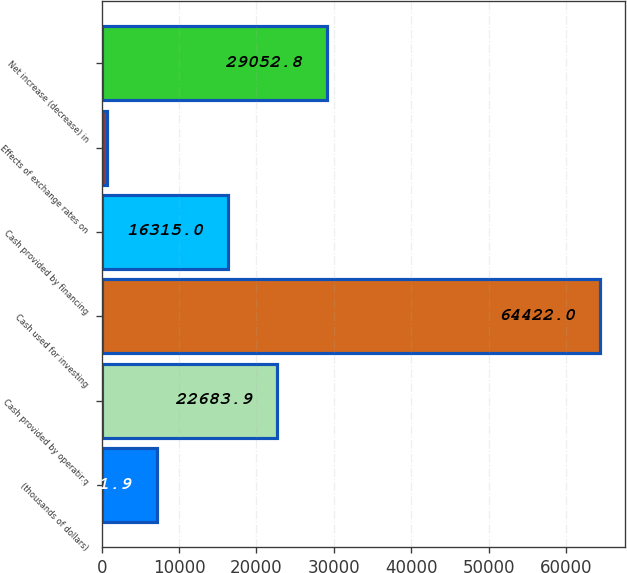<chart> <loc_0><loc_0><loc_500><loc_500><bar_chart><fcel>(thousands of dollars)<fcel>Cash provided by operating<fcel>Cash used for investing<fcel>Cash provided by financing<fcel>Effects of exchange rates on<fcel>Net increase (decrease) in<nl><fcel>7101.9<fcel>22683.9<fcel>64422<fcel>16315<fcel>733<fcel>29052.8<nl></chart> 